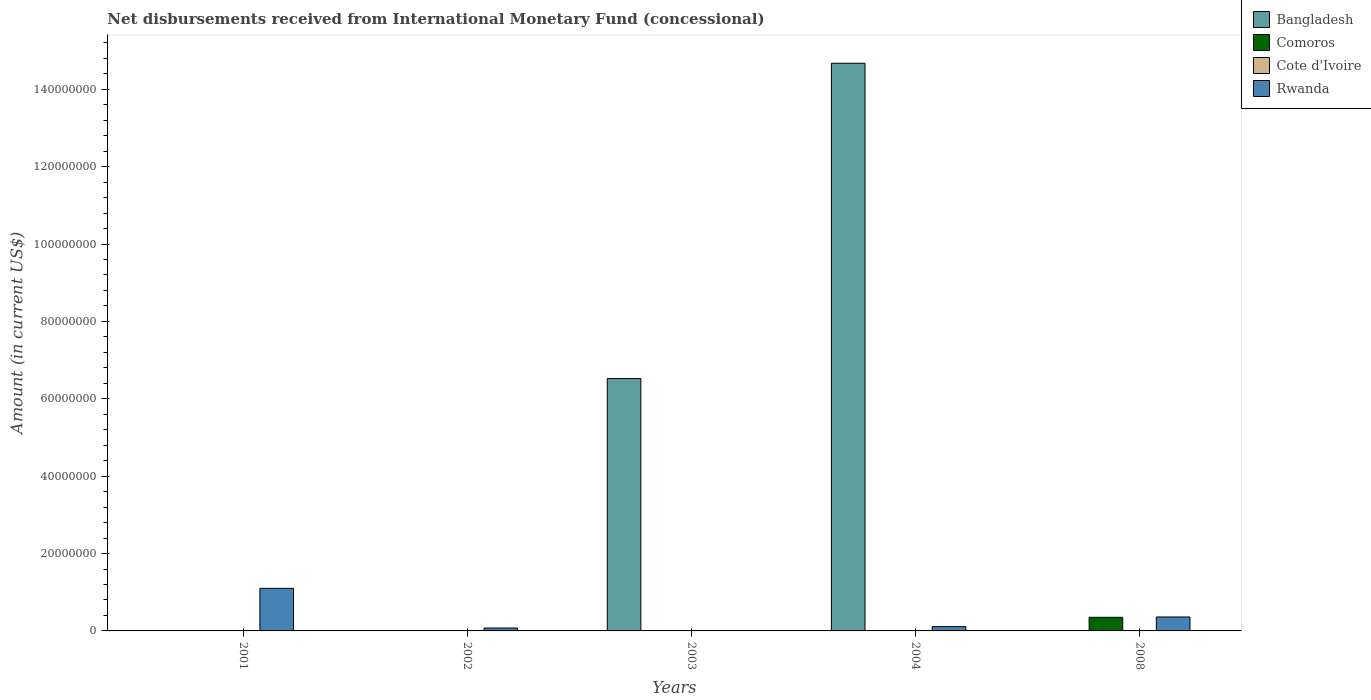Are the number of bars on each tick of the X-axis equal?
Provide a succinct answer. No. In how many cases, is the number of bars for a given year not equal to the number of legend labels?
Your answer should be compact. 5. Across all years, what is the maximum amount of disbursements received from International Monetary Fund in Rwanda?
Your response must be concise. 1.10e+07. Across all years, what is the minimum amount of disbursements received from International Monetary Fund in Rwanda?
Your answer should be very brief. 0. In which year was the amount of disbursements received from International Monetary Fund in Bangladesh maximum?
Provide a succinct answer. 2004. What is the total amount of disbursements received from International Monetary Fund in Comoros in the graph?
Your answer should be very brief. 3.52e+06. What is the difference between the amount of disbursements received from International Monetary Fund in Rwanda in 2004 and that in 2008?
Provide a short and direct response. -2.49e+06. What is the average amount of disbursements received from International Monetary Fund in Cote d'Ivoire per year?
Keep it short and to the point. 0. In how many years, is the amount of disbursements received from International Monetary Fund in Comoros greater than 32000000 US$?
Offer a terse response. 0. Is the amount of disbursements received from International Monetary Fund in Bangladesh in 2003 less than that in 2004?
Your response must be concise. Yes. What is the difference between the highest and the second highest amount of disbursements received from International Monetary Fund in Rwanda?
Make the answer very short. 7.40e+06. What is the difference between the highest and the lowest amount of disbursements received from International Monetary Fund in Rwanda?
Keep it short and to the point. 1.10e+07. How many bars are there?
Keep it short and to the point. 7. Are all the bars in the graph horizontal?
Ensure brevity in your answer.  No. How many years are there in the graph?
Keep it short and to the point. 5. What is the difference between two consecutive major ticks on the Y-axis?
Provide a short and direct response. 2.00e+07. Are the values on the major ticks of Y-axis written in scientific E-notation?
Offer a terse response. No. Does the graph contain grids?
Provide a short and direct response. No. What is the title of the graph?
Your response must be concise. Net disbursements received from International Monetary Fund (concessional). Does "Kuwait" appear as one of the legend labels in the graph?
Your answer should be compact. No. What is the label or title of the Y-axis?
Provide a short and direct response. Amount (in current US$). What is the Amount (in current US$) of Bangladesh in 2001?
Provide a succinct answer. 0. What is the Amount (in current US$) in Comoros in 2001?
Your answer should be very brief. 0. What is the Amount (in current US$) in Rwanda in 2001?
Offer a very short reply. 1.10e+07. What is the Amount (in current US$) in Bangladesh in 2002?
Your response must be concise. 0. What is the Amount (in current US$) in Comoros in 2002?
Ensure brevity in your answer.  0. What is the Amount (in current US$) in Cote d'Ivoire in 2002?
Ensure brevity in your answer.  0. What is the Amount (in current US$) of Rwanda in 2002?
Provide a succinct answer. 7.43e+05. What is the Amount (in current US$) in Bangladesh in 2003?
Offer a very short reply. 6.52e+07. What is the Amount (in current US$) in Cote d'Ivoire in 2003?
Your answer should be very brief. 0. What is the Amount (in current US$) in Rwanda in 2003?
Your answer should be compact. 0. What is the Amount (in current US$) of Bangladesh in 2004?
Your answer should be compact. 1.47e+08. What is the Amount (in current US$) in Comoros in 2004?
Your answer should be compact. 0. What is the Amount (in current US$) of Cote d'Ivoire in 2004?
Keep it short and to the point. 0. What is the Amount (in current US$) of Rwanda in 2004?
Offer a very short reply. 1.11e+06. What is the Amount (in current US$) of Comoros in 2008?
Offer a very short reply. 3.52e+06. What is the Amount (in current US$) of Rwanda in 2008?
Provide a short and direct response. 3.60e+06. Across all years, what is the maximum Amount (in current US$) of Bangladesh?
Your response must be concise. 1.47e+08. Across all years, what is the maximum Amount (in current US$) of Comoros?
Give a very brief answer. 3.52e+06. Across all years, what is the maximum Amount (in current US$) in Rwanda?
Offer a terse response. 1.10e+07. Across all years, what is the minimum Amount (in current US$) of Rwanda?
Give a very brief answer. 0. What is the total Amount (in current US$) in Bangladesh in the graph?
Keep it short and to the point. 2.12e+08. What is the total Amount (in current US$) of Comoros in the graph?
Your response must be concise. 3.52e+06. What is the total Amount (in current US$) of Rwanda in the graph?
Offer a terse response. 1.65e+07. What is the difference between the Amount (in current US$) of Rwanda in 2001 and that in 2002?
Offer a very short reply. 1.03e+07. What is the difference between the Amount (in current US$) of Rwanda in 2001 and that in 2004?
Ensure brevity in your answer.  9.89e+06. What is the difference between the Amount (in current US$) of Rwanda in 2001 and that in 2008?
Provide a succinct answer. 7.40e+06. What is the difference between the Amount (in current US$) in Rwanda in 2002 and that in 2004?
Your response must be concise. -3.70e+05. What is the difference between the Amount (in current US$) of Rwanda in 2002 and that in 2008?
Your answer should be very brief. -2.86e+06. What is the difference between the Amount (in current US$) in Bangladesh in 2003 and that in 2004?
Provide a short and direct response. -8.15e+07. What is the difference between the Amount (in current US$) in Rwanda in 2004 and that in 2008?
Keep it short and to the point. -2.49e+06. What is the difference between the Amount (in current US$) of Bangladesh in 2003 and the Amount (in current US$) of Rwanda in 2004?
Provide a succinct answer. 6.41e+07. What is the difference between the Amount (in current US$) of Bangladesh in 2003 and the Amount (in current US$) of Comoros in 2008?
Keep it short and to the point. 6.17e+07. What is the difference between the Amount (in current US$) in Bangladesh in 2003 and the Amount (in current US$) in Rwanda in 2008?
Your answer should be very brief. 6.16e+07. What is the difference between the Amount (in current US$) in Bangladesh in 2004 and the Amount (in current US$) in Comoros in 2008?
Your answer should be very brief. 1.43e+08. What is the difference between the Amount (in current US$) of Bangladesh in 2004 and the Amount (in current US$) of Rwanda in 2008?
Provide a succinct answer. 1.43e+08. What is the average Amount (in current US$) of Bangladesh per year?
Give a very brief answer. 4.24e+07. What is the average Amount (in current US$) of Comoros per year?
Your response must be concise. 7.03e+05. What is the average Amount (in current US$) in Rwanda per year?
Give a very brief answer. 3.29e+06. In the year 2004, what is the difference between the Amount (in current US$) of Bangladesh and Amount (in current US$) of Rwanda?
Your answer should be compact. 1.46e+08. In the year 2008, what is the difference between the Amount (in current US$) of Comoros and Amount (in current US$) of Rwanda?
Give a very brief answer. -8.70e+04. What is the ratio of the Amount (in current US$) of Rwanda in 2001 to that in 2002?
Give a very brief answer. 14.81. What is the ratio of the Amount (in current US$) in Rwanda in 2001 to that in 2004?
Your answer should be compact. 9.89. What is the ratio of the Amount (in current US$) of Rwanda in 2001 to that in 2008?
Offer a very short reply. 3.05. What is the ratio of the Amount (in current US$) in Rwanda in 2002 to that in 2004?
Offer a terse response. 0.67. What is the ratio of the Amount (in current US$) of Rwanda in 2002 to that in 2008?
Your response must be concise. 0.21. What is the ratio of the Amount (in current US$) of Bangladesh in 2003 to that in 2004?
Offer a very short reply. 0.44. What is the ratio of the Amount (in current US$) in Rwanda in 2004 to that in 2008?
Ensure brevity in your answer.  0.31. What is the difference between the highest and the second highest Amount (in current US$) of Rwanda?
Give a very brief answer. 7.40e+06. What is the difference between the highest and the lowest Amount (in current US$) of Bangladesh?
Offer a terse response. 1.47e+08. What is the difference between the highest and the lowest Amount (in current US$) in Comoros?
Keep it short and to the point. 3.52e+06. What is the difference between the highest and the lowest Amount (in current US$) of Rwanda?
Your answer should be compact. 1.10e+07. 